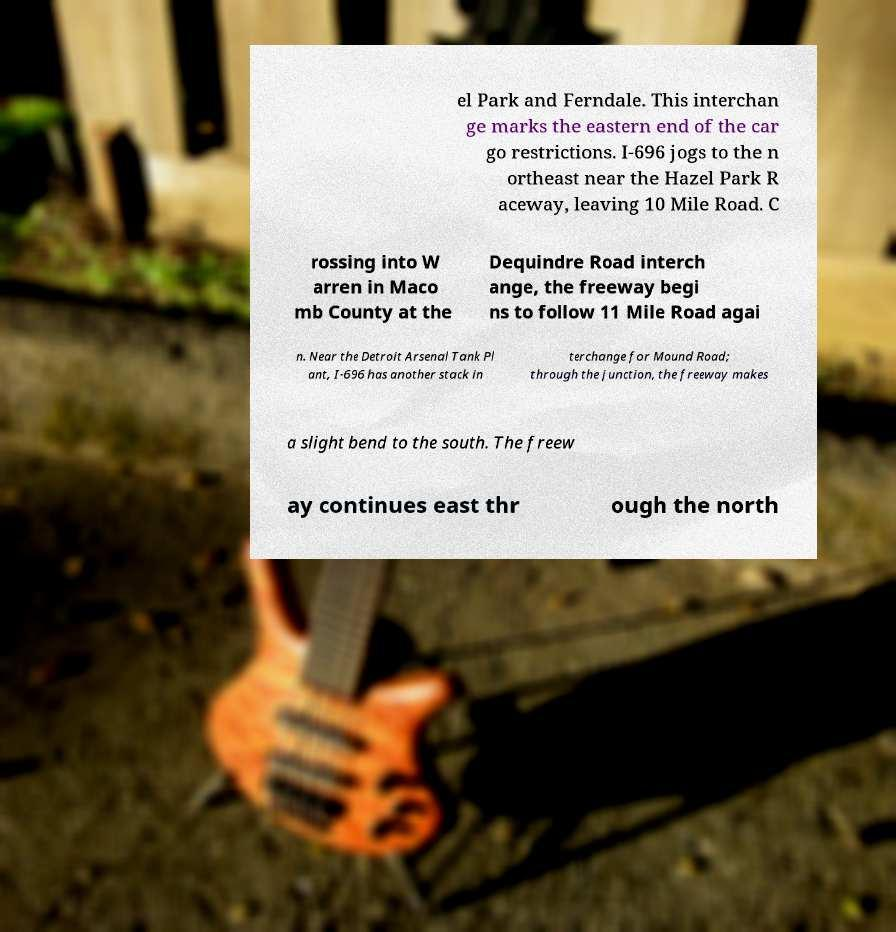There's text embedded in this image that I need extracted. Can you transcribe it verbatim? el Park and Ferndale. This interchan ge marks the eastern end of the car go restrictions. I-696 jogs to the n ortheast near the Hazel Park R aceway, leaving 10 Mile Road. C rossing into W arren in Maco mb County at the Dequindre Road interch ange, the freeway begi ns to follow 11 Mile Road agai n. Near the Detroit Arsenal Tank Pl ant, I-696 has another stack in terchange for Mound Road; through the junction, the freeway makes a slight bend to the south. The freew ay continues east thr ough the north 